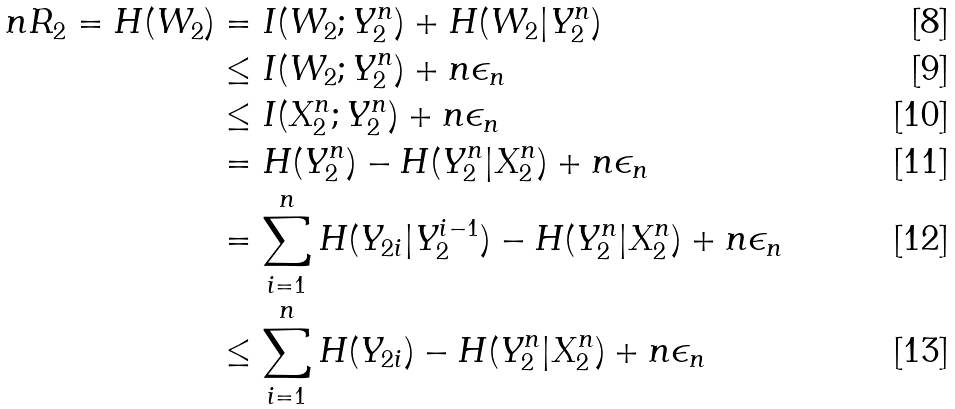<formula> <loc_0><loc_0><loc_500><loc_500>n R _ { 2 } = H ( W _ { 2 } ) & = I ( W _ { 2 } ; Y _ { 2 } ^ { n } ) + H ( W _ { 2 } | Y _ { 2 } ^ { n } ) \\ & \leq I ( W _ { 2 } ; Y _ { 2 } ^ { n } ) + n \epsilon _ { n } \\ & \leq I ( X _ { 2 } ^ { n } ; Y _ { 2 } ^ { n } ) + n \epsilon _ { n } \\ & = H ( Y _ { 2 } ^ { n } ) - H ( Y _ { 2 } ^ { n } | X _ { 2 } ^ { n } ) + n \epsilon _ { n } \\ & = \sum _ { i = 1 } ^ { n } H ( Y _ { 2 i } | Y _ { 2 } ^ { i - 1 } ) - H ( Y _ { 2 } ^ { n } | X _ { 2 } ^ { n } ) + n \epsilon _ { n } \\ & \leq \sum _ { i = 1 } ^ { n } H ( Y _ { 2 i } ) - H ( Y _ { 2 } ^ { n } | X _ { 2 } ^ { n } ) + n \epsilon _ { n }</formula> 